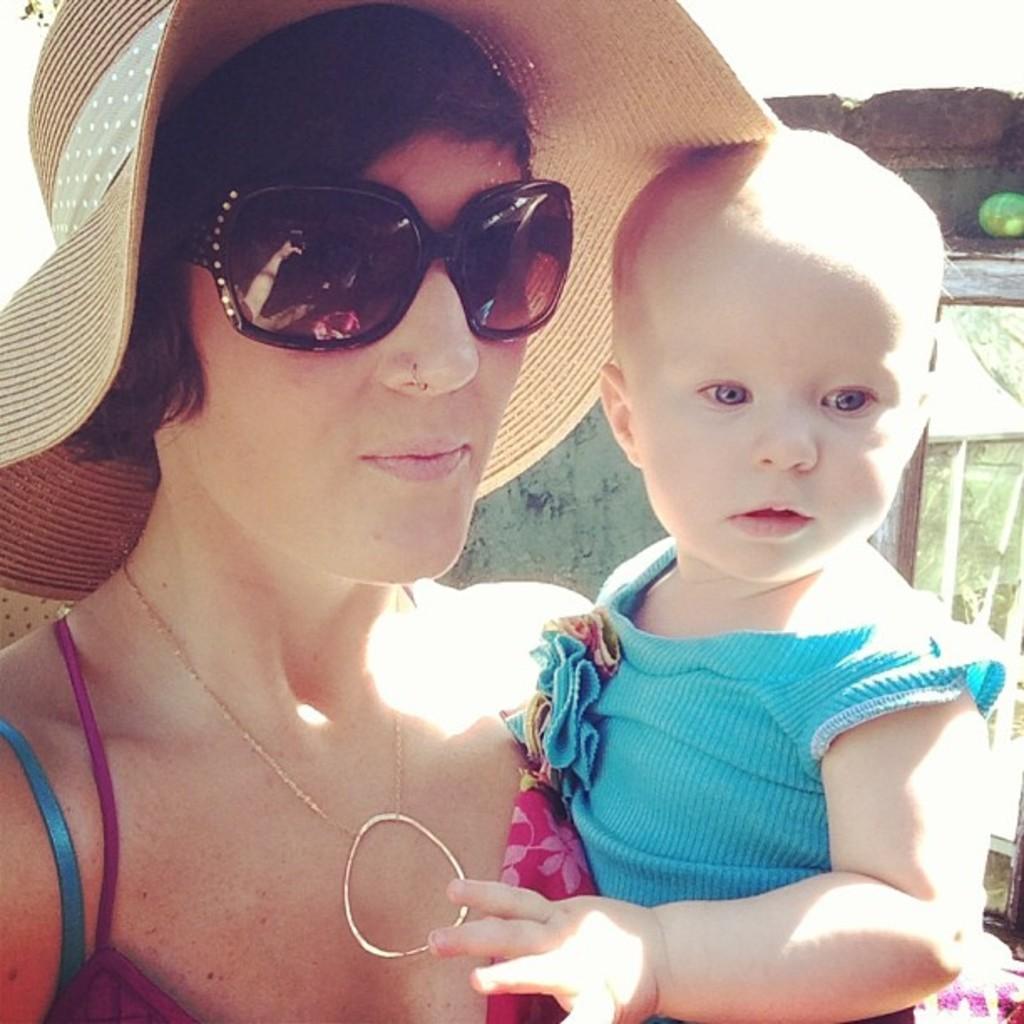Could you give a brief overview of what you see in this image? In this image, we can see a woman and baby. Woman is wearing goggles and hat. Background we can see a wall. 